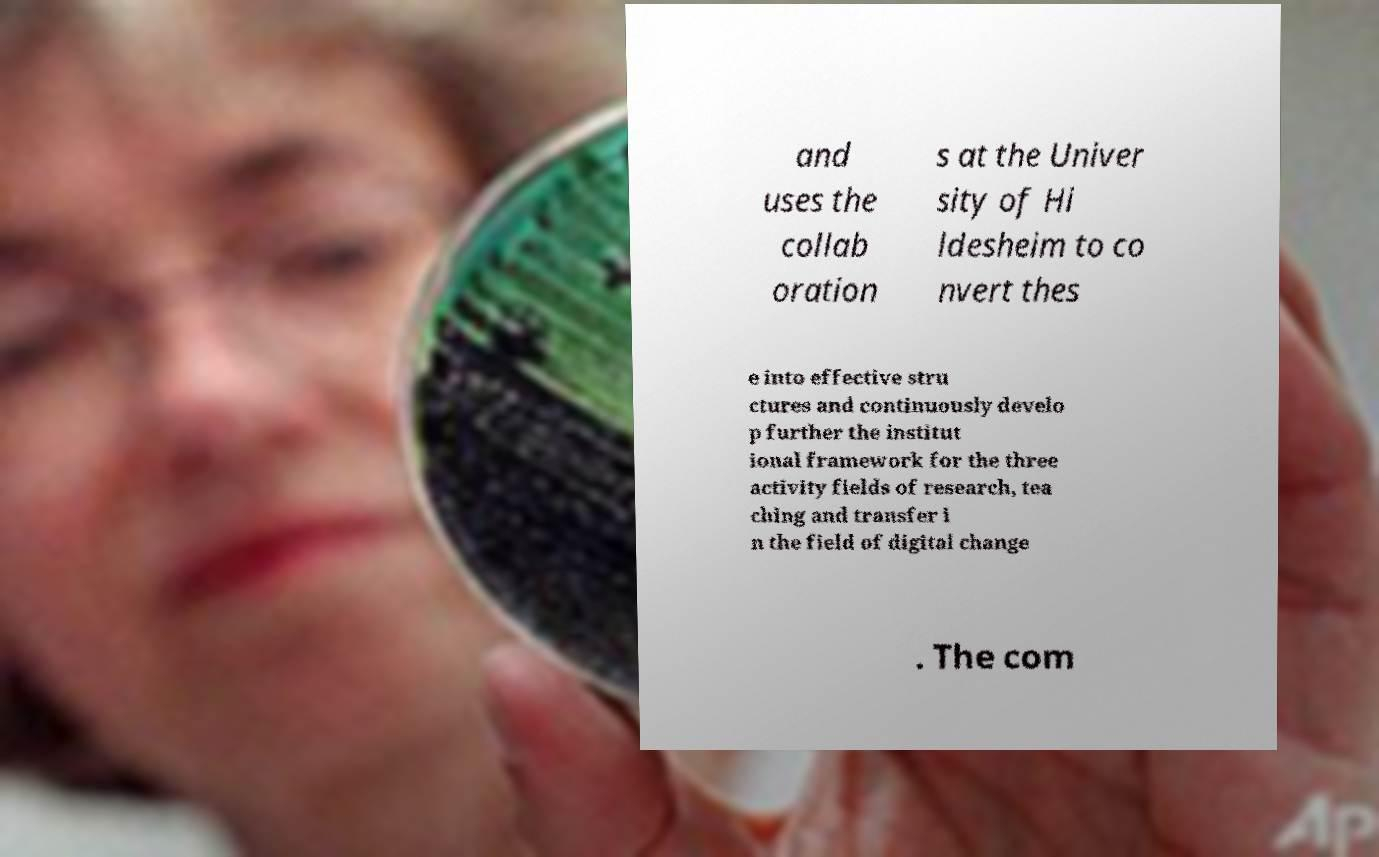There's text embedded in this image that I need extracted. Can you transcribe it verbatim? and uses the collab oration s at the Univer sity of Hi ldesheim to co nvert thes e into effective stru ctures and continuously develo p further the institut ional framework for the three activity fields of research, tea ching and transfer i n the field of digital change . The com 